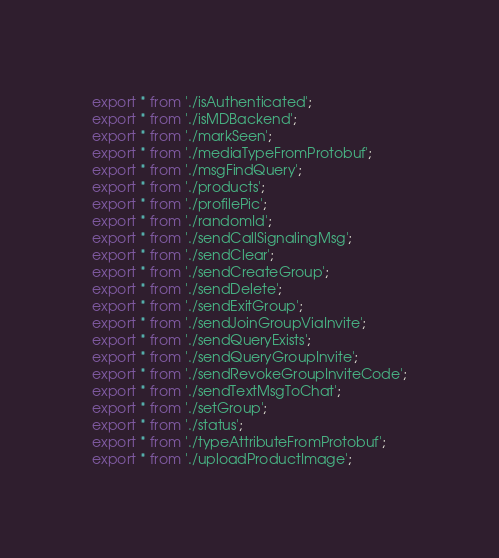Convert code to text. <code><loc_0><loc_0><loc_500><loc_500><_TypeScript_>export * from './isAuthenticated';
export * from './isMDBackend';
export * from './markSeen';
export * from './mediaTypeFromProtobuf';
export * from './msgFindQuery';
export * from './products';
export * from './profilePic';
export * from './randomId';
export * from './sendCallSignalingMsg';
export * from './sendClear';
export * from './sendCreateGroup';
export * from './sendDelete';
export * from './sendExitGroup';
export * from './sendJoinGroupViaInvite';
export * from './sendQueryExists';
export * from './sendQueryGroupInvite';
export * from './sendRevokeGroupInviteCode';
export * from './sendTextMsgToChat';
export * from './setGroup';
export * from './status';
export * from './typeAttributeFromProtobuf';
export * from './uploadProductImage';
</code> 